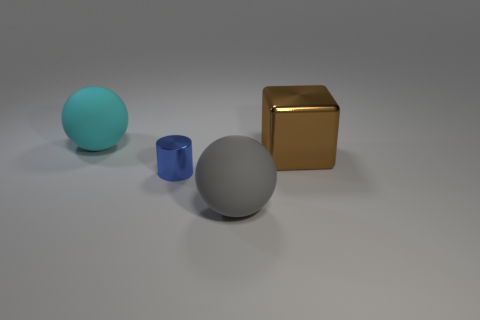Can you describe the lighting situation in the scene? The lighting in the image is diffuse with soft shadows, indicating an overcast or ambient light source. The way the light reflects off the objects, particularly the golden cube and the cyan sphere, suggests the presence of a broad light source overhead. The lack of harsh shadows or direct reflections also implies that the environment does not have a strong singular light source like the sun on a clear day or a spotlight. 